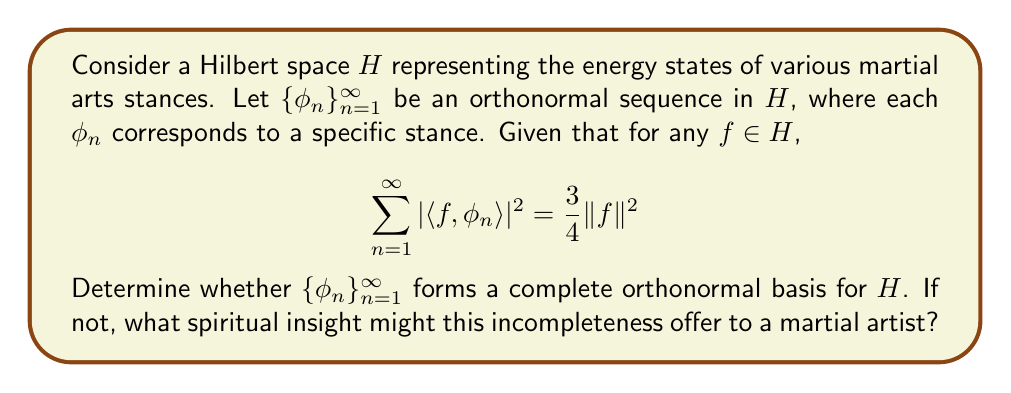Teach me how to tackle this problem. To determine if $\{\phi_n\}_{n=1}^{\infty}$ forms a complete orthonormal basis for $H$, we need to check if it satisfies Parseval's identity.

1) For a complete orthonormal basis, Parseval's identity states that for any $f \in H$:

   $$\sum_{n=1}^{\infty} |\langle f, \phi_n \rangle|^2 = \|f\|^2$$

2) In our case, we are given:

   $$\sum_{n=1}^{\infty} |\langle f, \phi_n \rangle|^2 = \frac{3}{4} \|f\|^2$$

3) Comparing these two equations, we can see that the given sequence does not satisfy Parseval's identity, as the right-hand side is $\frac{3}{4} \|f\|^2$ instead of $\|f\|^2$.

4) This means that $\{\phi_n\}_{n=1}^{\infty}$ is not a complete orthonormal basis for $H$.

5) The completeness defect is $1 - \frac{3}{4} = \frac{1}{4}$, indicating that the sequence captures only 75% of the energy of any vector in the space.

From a spiritual martial arts perspective, this incompleteness could be interpreted as follows:

- The 75% completeness might represent the physical and mental aspects of martial arts that can be formally described and practiced.
- The missing 25% could symbolize the intangible, spiritual aspect of martial arts that goes beyond formal stances and techniques - the part that can only be realized through deep personal experience and inner growth.
- This mathematical result reminds us that while structured training (represented by the orthonormal sequence) is crucial, it doesn't encompass the entire essence of martial arts. There's always a transcendent element that lies beyond formal representation.
Answer: $\{\phi_n\}_{n=1}^{\infty}$ does not form a complete orthonormal basis for $H$. The sequence has a completeness defect of $\frac{1}{4}$, capturing only 75% of the energy of any vector in the space. 